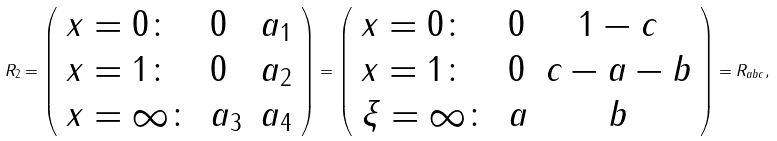<formula> <loc_0><loc_0><loc_500><loc_500>R _ { 2 } = \left ( \begin{array} { l l l } x = 0 \colon & 0 & a _ { 1 } \\ x = 1 \colon & 0 & a _ { 2 } \\ x = \infty \colon & a _ { 3 } & a _ { 4 } \end{array} \right ) = \left ( \begin{array} { l l c } x = 0 \colon & 0 & 1 - c \\ x = 1 \colon & 0 & c - a - b \\ \xi = \infty \colon & a & b \end{array} \right ) = R _ { a b c } ,</formula> 